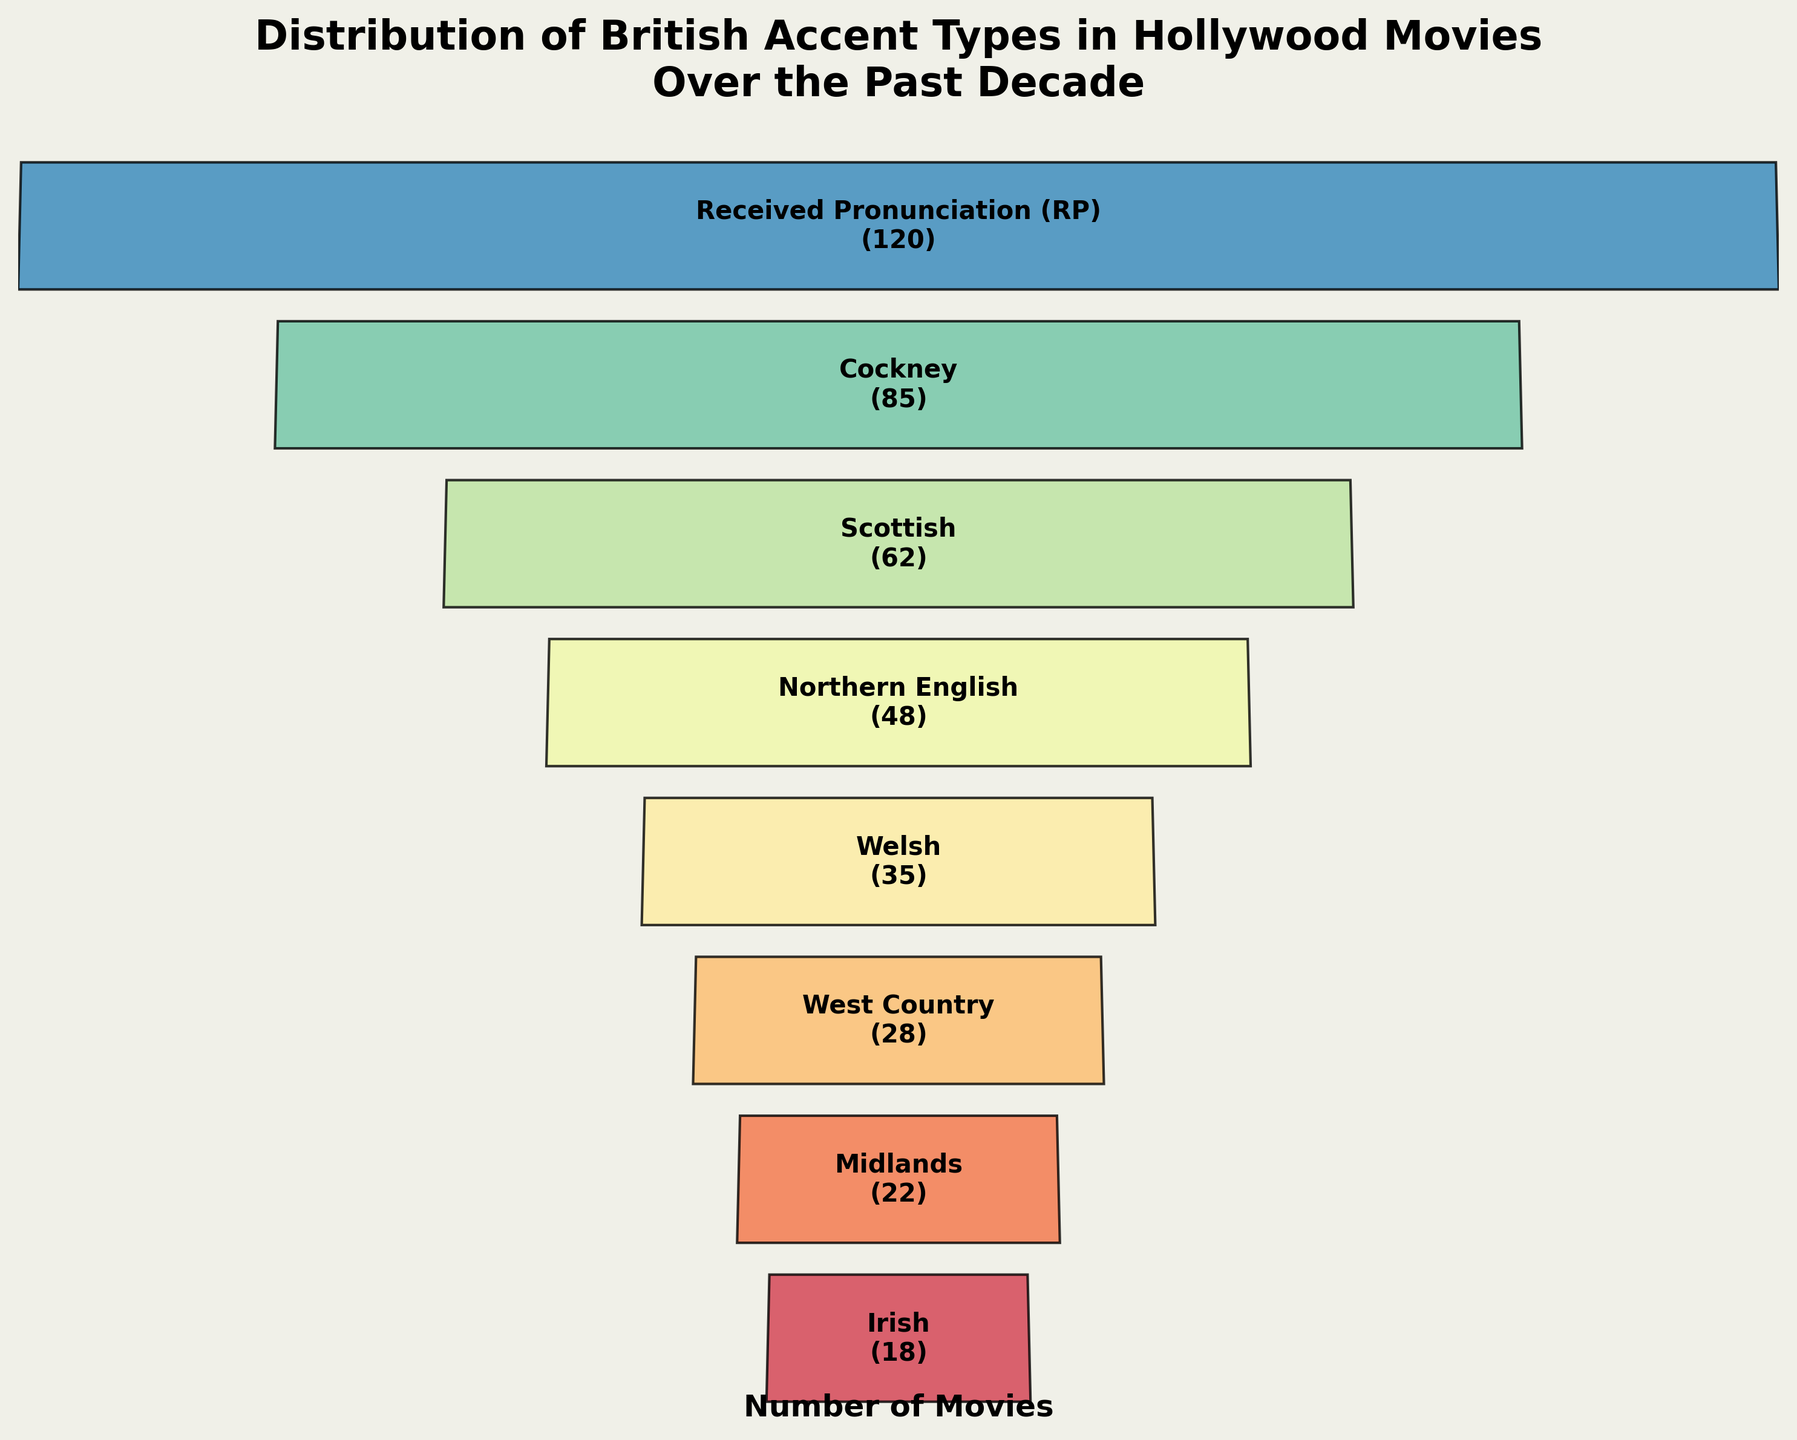Which accent type appears in the most Hollywood movies over the past decade? Look for the accent type with the largest number next to its label. In this case, "Received Pronunciation (RP)" has 120 movies.
Answer: Received Pronunciation (RP) What is the total number of movies featuring Cockney and Scottish accents combined? Find the values for Cockney (85) and Scottish (62), and sum them up: 85 + 62 = 147.
Answer: 147 Which two accent types have the least number of movies, and how many movies are there for each? Identify the two lowest values in the list, which are "Irish" with 18 movies and "Midlands" with 22 movies.
Answer: Irish (18) and Midlands (22) How many more movies feature Received Pronunciation (RP) than Welsh accents? Subtract the number of Welsh movies from Received Pronunciation (RP) movies: 120 - 35 = 85.
Answer: 85 What percentage of the total movies do Cockney accents represent? Sum all the movies: 120 + 85 + 62 + 48 + 35 + 28 + 22 + 18 = 418. Then calculate the percentage: (85 / 418) * 100 ≈ 20.33%.
Answer: 20.33% Which accent type is most commonly represented in movies after Received Pronunciation (RP)? Look for the second-largest number of movies. In this case, Cockney with 85 movies.
Answer: Cockney How many movies in total feature either Northern English or West Country accents combined? Find the values for Northern English (48) and West Country (28), and sum them up: 48 + 28 = 76.
Answer: 76 Which accent types have fewer than 30 movies? Identify the accent types with values less than 30. In this case, West Country (28), Midlands (22), and Irish (18).
Answer: West Country, Midlands, and Irish How many more movies feature Scottish accents than Irish accents? Subtract the number of Irish movies from Scottish movies: 62 - 18 = 44.
Answer: 44 What is the average number of movies across all accent types? Sum all the movies: 120 + 85 + 62 + 48 + 35 + 28 + 22 + 18 = 418. Divide by the number of accent types, which is 8: 418 / 8 = 52.25.
Answer: 52.25 